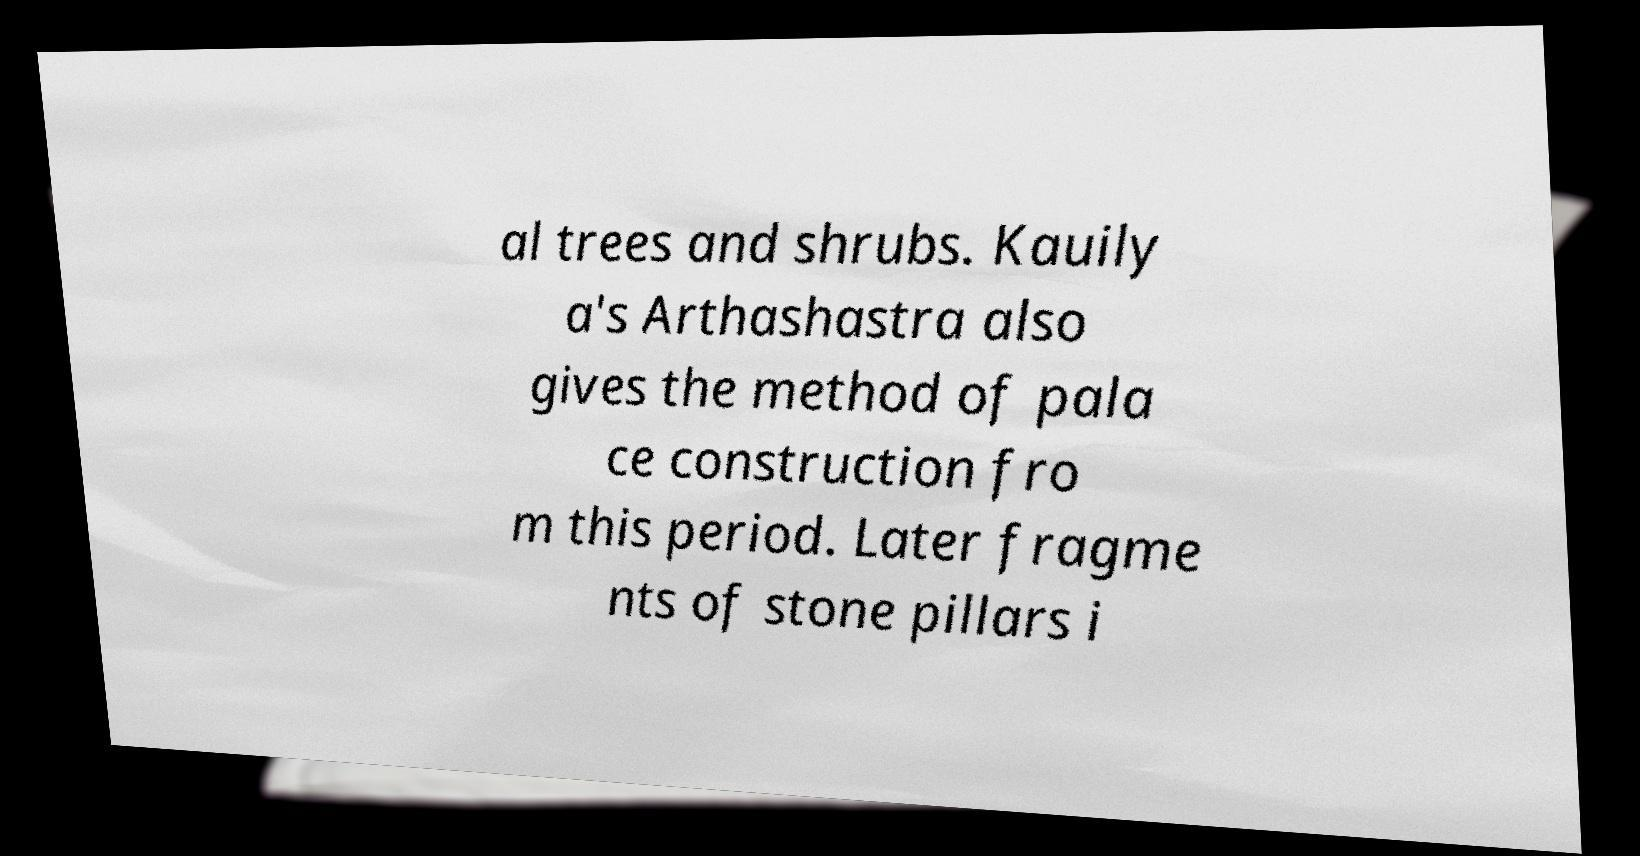Could you assist in decoding the text presented in this image and type it out clearly? al trees and shrubs. Kauily a's Arthashastra also gives the method of pala ce construction fro m this period. Later fragme nts of stone pillars i 